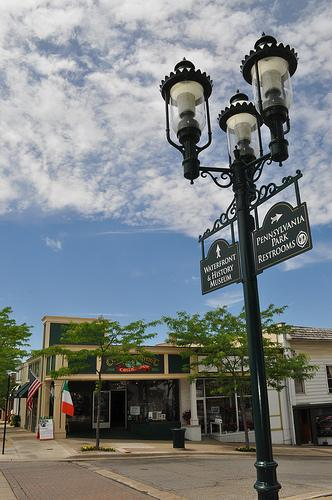Describe the elements in the image related to nature. There are small young trees with green leaves and a small patch of yellow flowers near the paved city street. Assess the quality of this image in terms of the objects' clarity. The image quality is decent, but objects are small and might be difficult to identify without additional context. Mention an interesting detail about the light pole. The light pole is black and has three unlit lanterns attached to it. Write a short caption for this image. Urban scene with flags, signs, street lamps, and trees. Identify the types and colors of flags in the image. There's an American flag (red, white, and blue) and an Italian flag (green, white, and red). Explain the layout of the sidewalk based on the objects present. On the sidewalk, there are signs, trees, a green garbage can, a black trash can, and a brick paved crosswalk. What are the colors of the different signs? There're red, green, tan, and a red-and-green sidewalk sign. How many signs are pointing to restrooms? Two signs are pointing to restrooms. Provide an emotion that this image might evoke. Sense of curiosity and exploration of an urban environment. What kind of trees are present in the image? A few small young trees with green leaves. What type of event is taking place in the image? No specific event is taking place. Can you notice the purple umbrella by the red car on the far right? This instruction is misleading because it mentions a specific color and an object that does not exist in the image. Additionally, it includes an interrogative sentence asking the user to notice the non-existent object. Are the three lanterns on the streetlamp lit or unlit? Unlit Describe the scene in the image using only nouns and prepositions. City street, flags, signs, awnings, lanterns, glass door, trash can, light pole, sky, flowers, trees. What color is the American flag in the image? Red, white, and blue Does the yellow bicycle parked near the open glass door have a broken tire? This instruction is misleading because it mentions a specific color and an object that is not present in the image. Moreover, it also raises an interrogative sentence asking the user to confirm the condition of the non-existent item. What architectural detail can be seen on one of the buildings in the image? Shingled roof A group of children is playing near the small young tree on the sidewalk. The instruction is misleading because it introduces new subjects (children) that are not present in the image. It also uses a declarative sentence to falsely describe a non-existent scene in the picture. Describe the scene in the image with appropriate adjectives and verbs. A picturesque cityscape features flags, signs, green awnings, lanterns, an open glass door, a green metal trash can, a black light pole, a cloudy blue sky, yellow flowers, and trees. How many unlit lanterns are there in the image? Three Where are the two signs located in the image? On the lamppost What is the content of the sign pointing to restrooms? Pennsylvania Park Restrooms What material is the trash can made of in the image? Metal What color is the sky in the image? Blue The vintage street clock next to the lamppost shows that it's almost noon. The instruction is misleading because it introduces a new object (a street clock) that does not exist in the image. It uses a declarative sentence to make a false statement about the non-existent object in the given context. Do you see the large mural on the building's wall with vibrant colors and abstract shapes? This instruction is misleading because it attempts to describe a detailed visual that does not exist in the image. It uses an interrogative sentence to question the user's ability to see a non-existent feature. What are the colors of the flowers in the image? Pink and yellow Look for a cat that's lounging on top of the green garbage can. The instruction is misleading because it introduces a new subject (a cat) that is not present in the image. It also uses a declarative sentence to suggest the user look for the non-existent subject in a specific location. What type of trees are present in the image? Small, young trees with green leaves Find the connection between the green sign with gold letters and the green garbage can. Both items are green. Which country's flag is located near the Italian flag? American flag Describe the crosswalk in the image. Brick paved Combine different elements in the image to create a fictional scenario. On a sunny day, a squirrel is playing next to the Italian flag while a man is looking for a restroom, following the sign on the lamppost. Identify any diagrams in the image and explain their purpose. There are no diagrams in the image. 